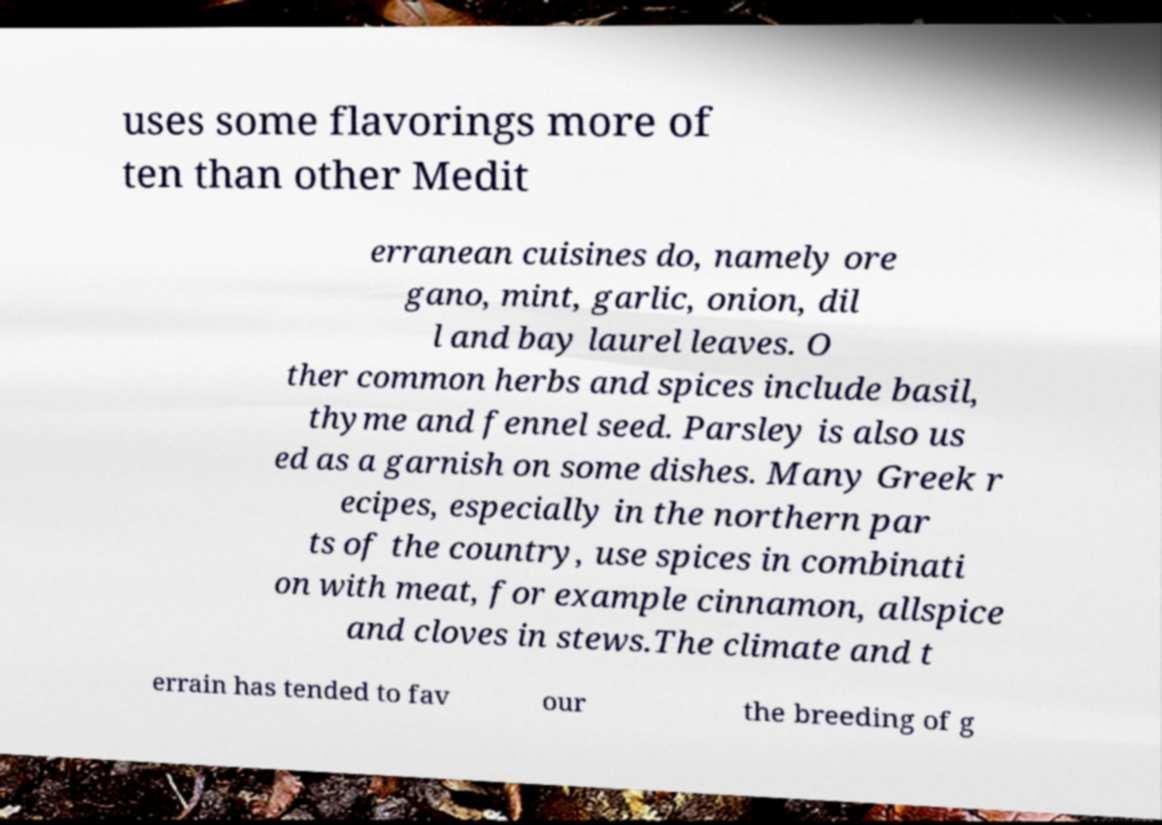I need the written content from this picture converted into text. Can you do that? uses some flavorings more of ten than other Medit erranean cuisines do, namely ore gano, mint, garlic, onion, dil l and bay laurel leaves. O ther common herbs and spices include basil, thyme and fennel seed. Parsley is also us ed as a garnish on some dishes. Many Greek r ecipes, especially in the northern par ts of the country, use spices in combinati on with meat, for example cinnamon, allspice and cloves in stews.The climate and t errain has tended to fav our the breeding of g 